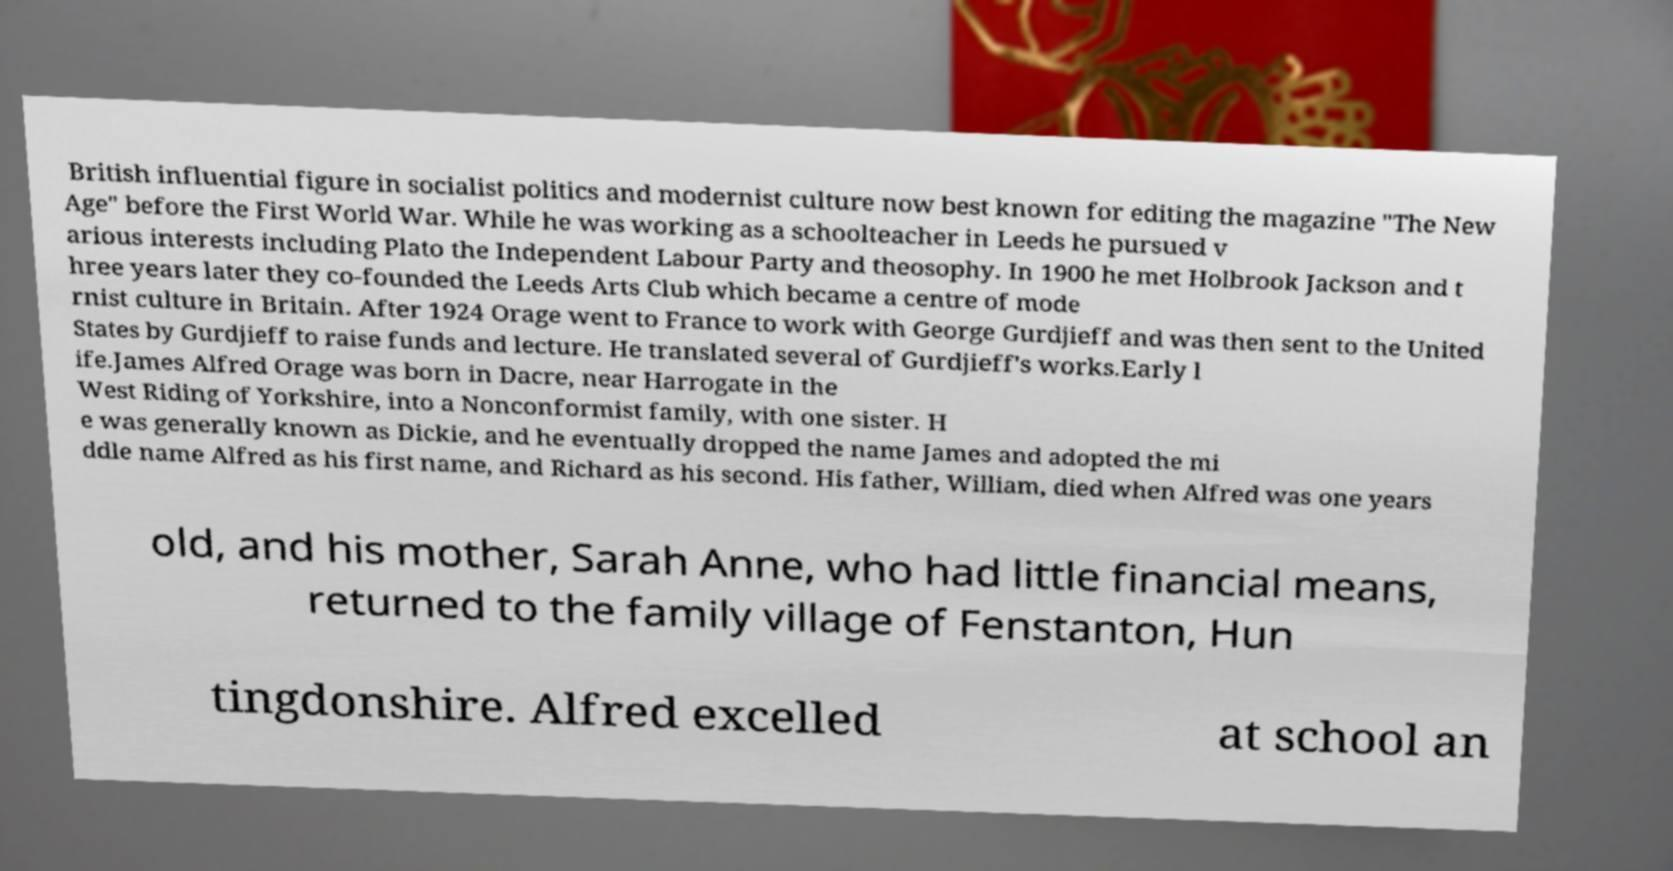Can you read and provide the text displayed in the image?This photo seems to have some interesting text. Can you extract and type it out for me? British influential figure in socialist politics and modernist culture now best known for editing the magazine "The New Age" before the First World War. While he was working as a schoolteacher in Leeds he pursued v arious interests including Plato the Independent Labour Party and theosophy. In 1900 he met Holbrook Jackson and t hree years later they co-founded the Leeds Arts Club which became a centre of mode rnist culture in Britain. After 1924 Orage went to France to work with George Gurdjieff and was then sent to the United States by Gurdjieff to raise funds and lecture. He translated several of Gurdjieff's works.Early l ife.James Alfred Orage was born in Dacre, near Harrogate in the West Riding of Yorkshire, into a Nonconformist family, with one sister. H e was generally known as Dickie, and he eventually dropped the name James and adopted the mi ddle name Alfred as his first name, and Richard as his second. His father, William, died when Alfred was one years old, and his mother, Sarah Anne, who had little financial means, returned to the family village of Fenstanton, Hun tingdonshire. Alfred excelled at school an 